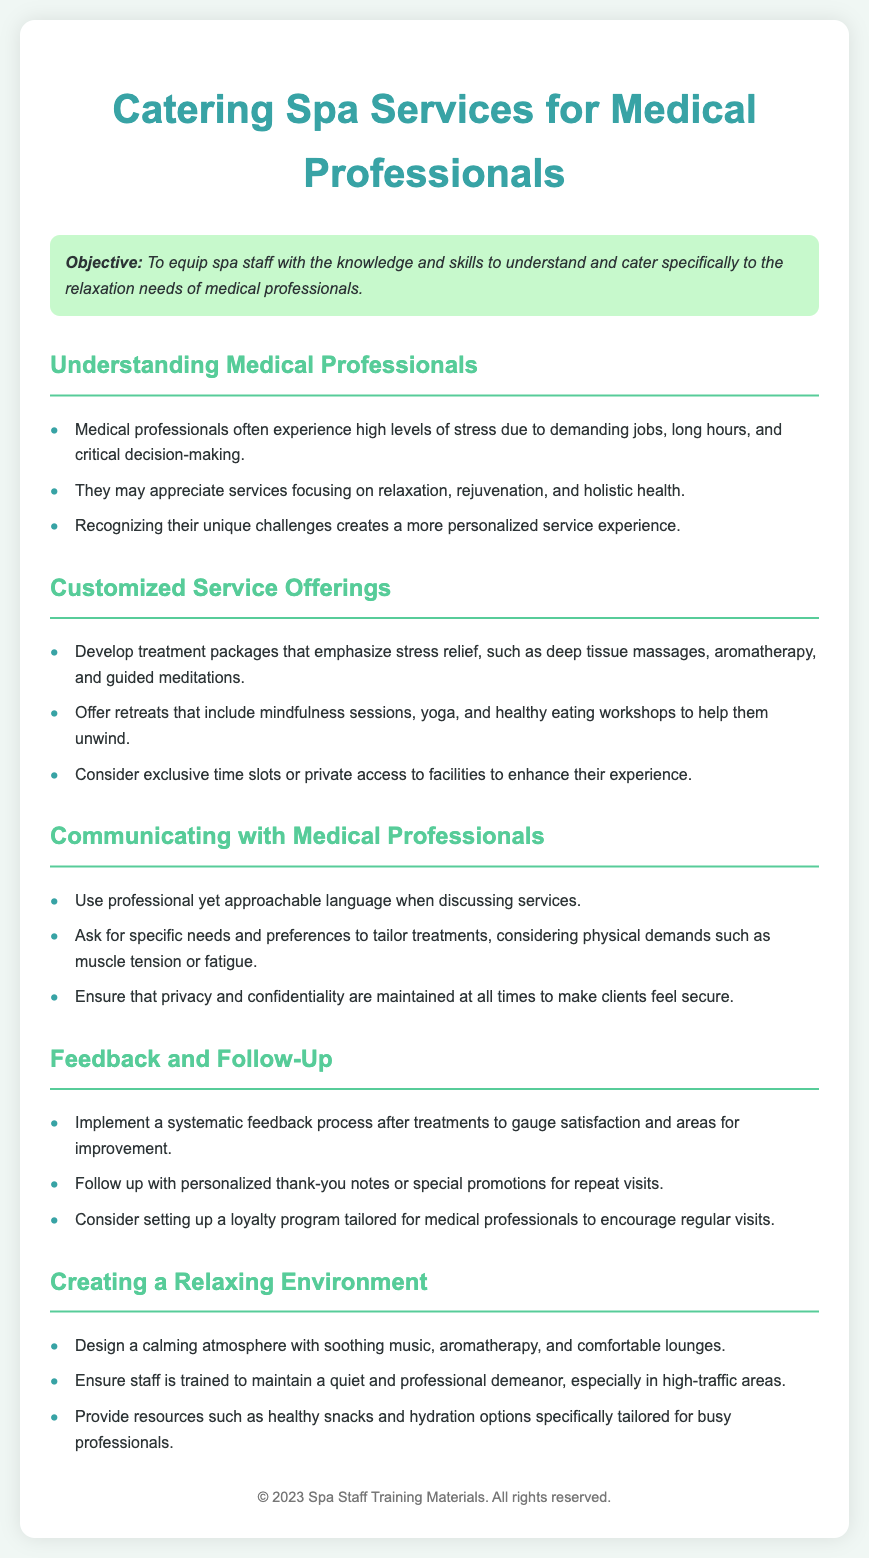What is the objective of the training? The objective of the training is to equip spa staff with the knowledge and skills to understand and cater specifically to the relaxation needs of medical professionals.
Answer: To equip spa staff with the knowledge and skills to understand and cater specifically to the relaxation needs of medical professionals What are key stress sources for medical professionals? The document mentions that medical professionals often experience high levels of stress due to demanding jobs, long hours, and critical decision-making.
Answer: Demanding jobs, long hours, and critical decision-making Name one customized treatment mentioned. The document lists several treatment packages that emphasize stress relief, and deep tissue massages is one of them.
Answer: Deep tissue massages What type of environment should be created for relaxation? The document emphasizes creating a calming atmosphere with soothing music, aromatherapy, and comfortable lounges.
Answer: Calming atmosphere with soothing music, aromatherapy, and comfortable lounges How can privacy be ensured for medical professionals? The document states that it is important to ensure that privacy and confidentiality are maintained at all times to make clients feel secure.
Answer: Privacy and confidentiality What type of follow-up is suggested in the document? The document suggests implementing a systematic feedback process after treatments to gauge satisfaction and areas for improvement.
Answer: Systematic feedback process What is one way to enhance experiences for medical professionals? The document proposes exclusive time slots or private access to facilities to enhance their experience.
Answer: Exclusive time slots or private access What type of snacks should be provided? The document suggests providing resources such as healthy snacks specifically tailored for busy professionals.
Answer: Healthy snacks What should staff be trained to maintain? The document mentions that staff should be trained to maintain a quiet and professional demeanor, especially in high-traffic areas.
Answer: Quiet and professional demeanor 